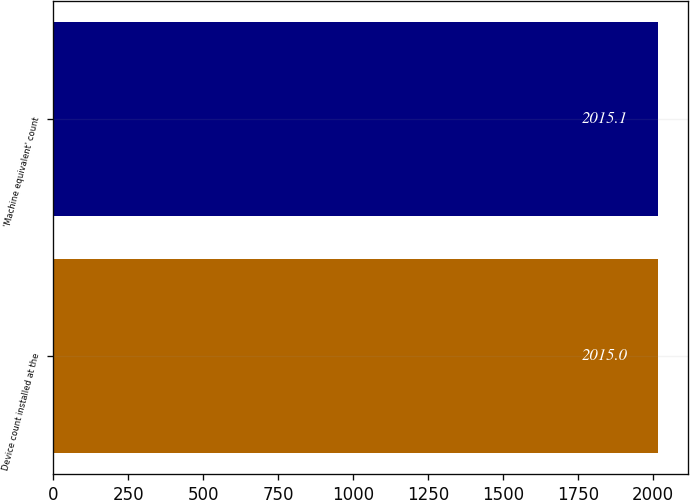Convert chart to OTSL. <chart><loc_0><loc_0><loc_500><loc_500><bar_chart><fcel>Device count installed at the<fcel>'Machine equivalent' count<nl><fcel>2015<fcel>2015.1<nl></chart> 